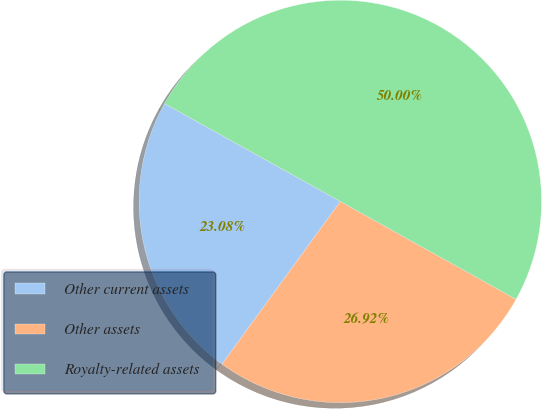Convert chart to OTSL. <chart><loc_0><loc_0><loc_500><loc_500><pie_chart><fcel>Other current assets<fcel>Other assets<fcel>Royalty-related assets<nl><fcel>23.08%<fcel>26.92%<fcel>50.0%<nl></chart> 